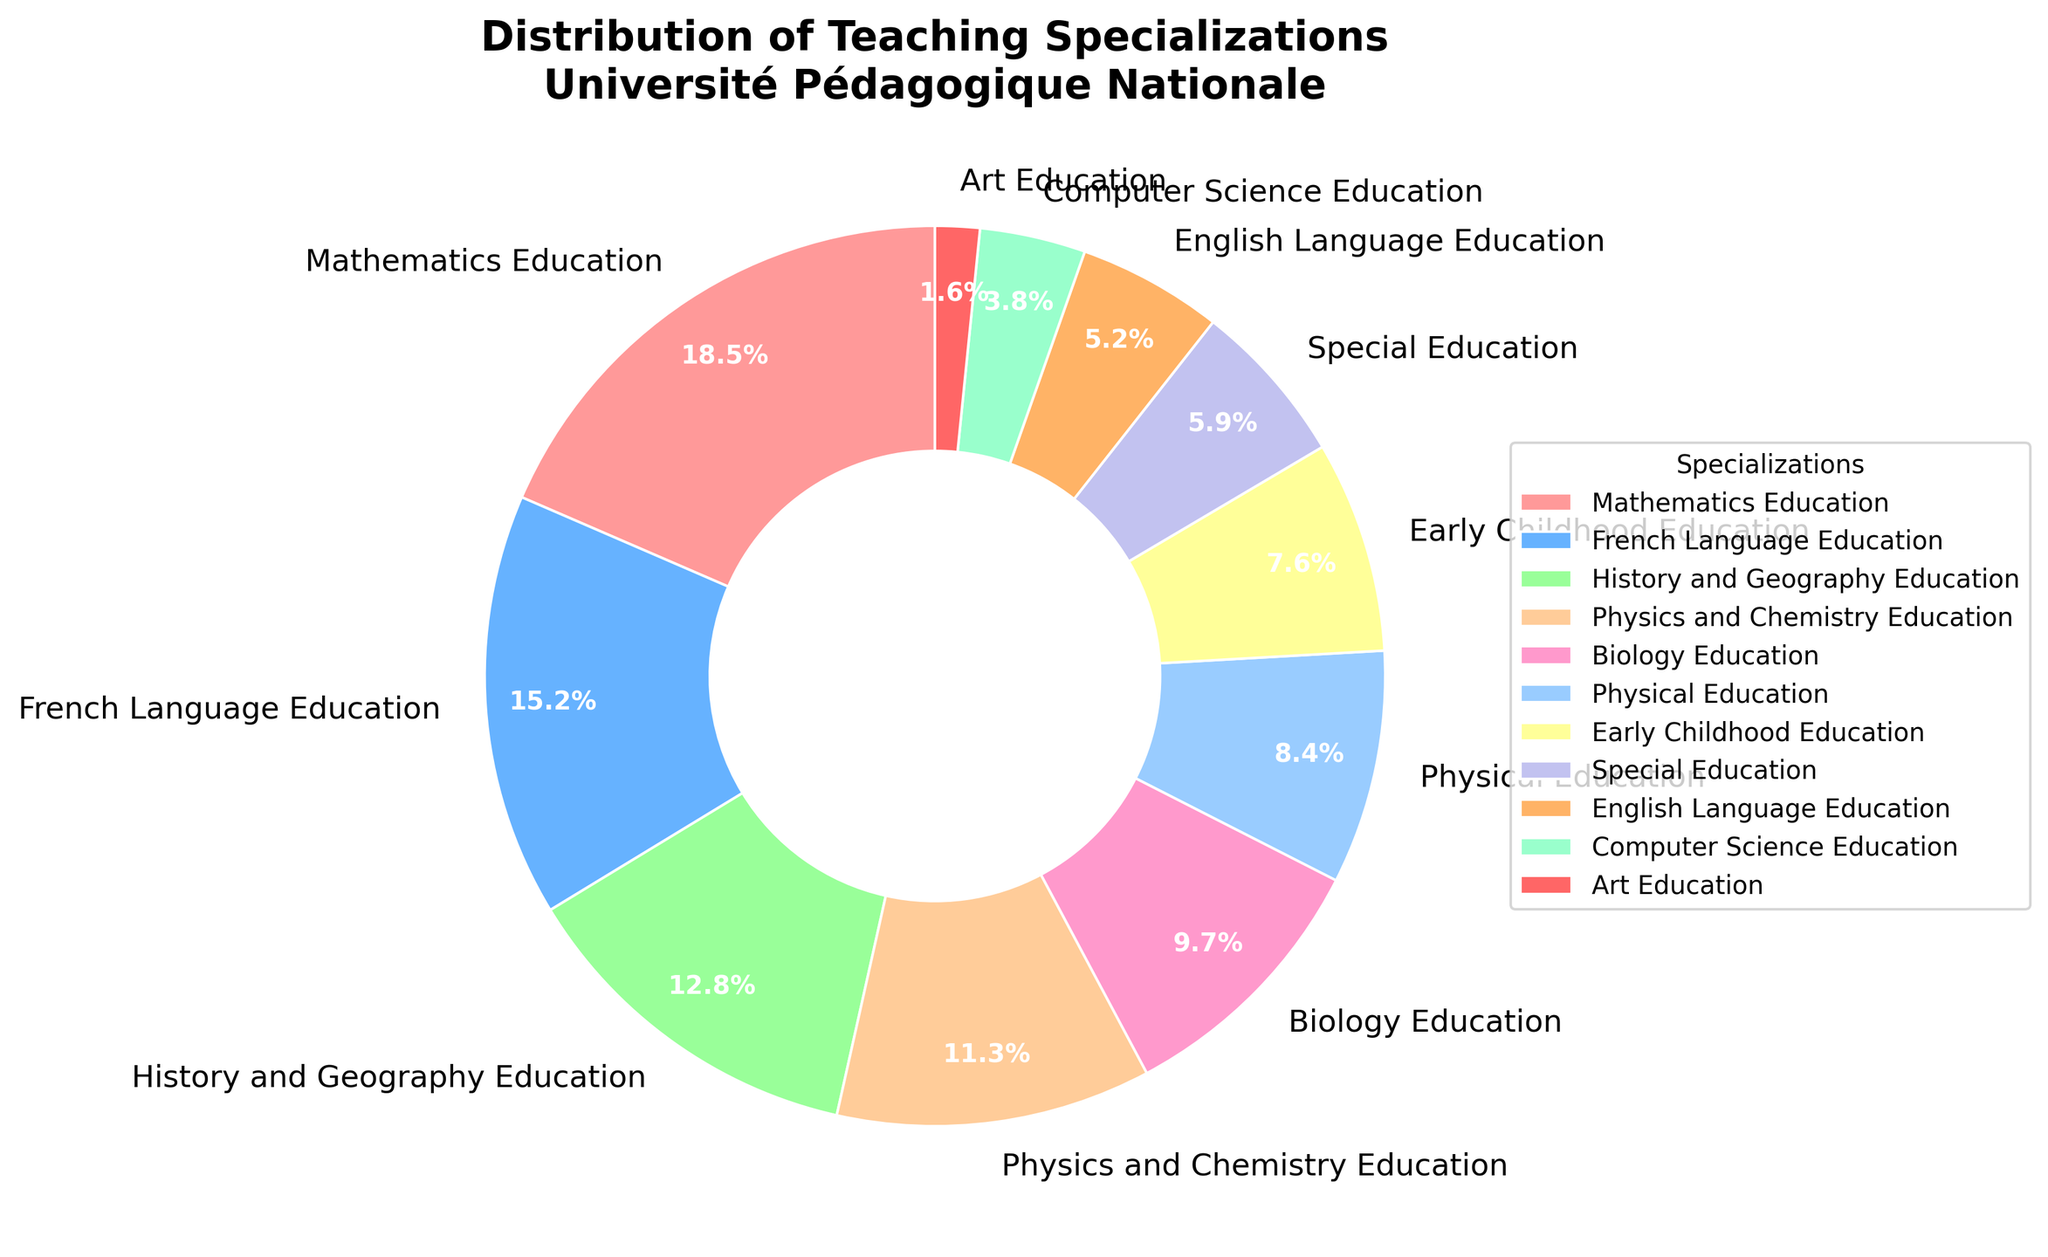What specialization has the highest percentage of graduates? By observing the figure, identify the segment with the largest slice. In this case, it is "Mathematics Education" as it has the highest marked percentage of 18.5%.
Answer: Mathematics Education Which two specializations together constitute the largest combined percentage? Add the percentages of all pairs and find the highest sum. The pair "Mathematics Education" (18.5%) and "French Language Education" (15.2%) has the largest combined percentage, totaling 33.7%.
Answer: Mathematics Education and French Language Education How does the percentage of Computer Science Education compare to that of Physical Education? Compare the marked percentages of the two specializations: Computer Science Education (3.8%) and Physical Education (8.4%).
Answer: The percentage of Physical Education is greater than that of Computer Science Education Which specialization accounts for the smallest percentage of graduates and what is that percentage? Identify the smallest slice in the pie chart, which corresponds to "Art Education" with a percentage of 1.6%.
Answer: Art Education, 1.6% What is the total percentage of graduates in Early Childhood Education, Special Education, and English Language Education combined? Sum the percentages of the three specializations: Early Childhood Education (7.6%) + Special Education (5.9%) + English Language Education (5.2%) = 18.7%.
Answer: 18.7% What is the approximate difference in percentage between Biology Education and Physics and Chemistry Education? Subtract the percentage of Physics and Chemistry Education (11.3%) from that of Biology Education (9.7%): 11.3% - 9.7% = 1.6%.
Answer: 1.6% Are there more graduates in French Language Education or History and Geography Education? Compare the percentages of both: French Language Education (15.2%) and History and Geography Education (12.8%).
Answer: French Language Education What is the combined percentage of Mathematics Education, French Language Education, and History and Geography Education? Sum the percentages of the three specializations: Mathematics Education (18.5%) + French Language Education (15.2%) + History and Geography Education (12.8%) = 46.5%.
Answer: 46.5% What percentage do the four specializations with the smallest percentages cumulatively contribute? Identify the four smallest percentages: Art Education (1.6%), Computer Science Education (3.8%), English Language Education (5.2%), and Special Education (5.9%). Sum them together: 1.6% + 3.8% + 5.2% + 5.9% = 16.5%.
Answer: 16.5% What is the proportion of Physical Education graduates compared to Biology Education graduates? Divide the percentage of Physical Education (8.4%) by the percentage of Biology Education (9.7%): 8.4 / 9.7 ≈ 0.87.
Answer: Approximately 0.87 